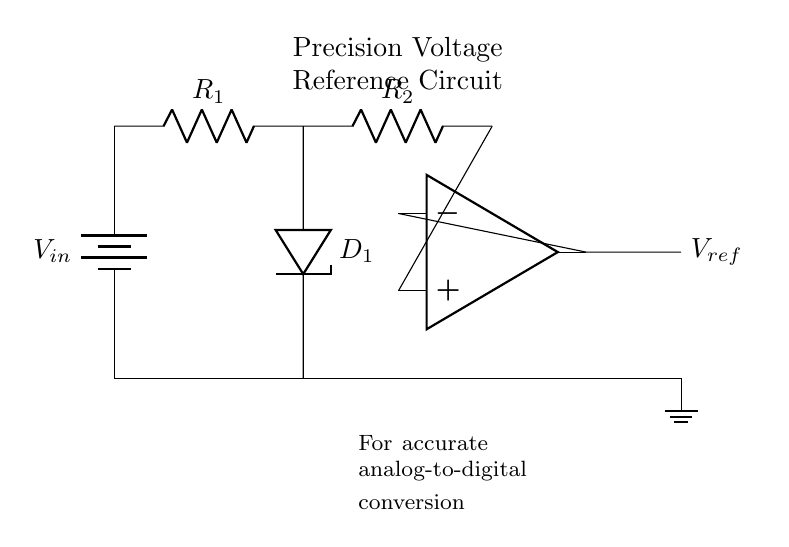What is the type of diode used in this circuit? The diagram indicates a Zener diode is used, which is represented as D1 in the circuit. Zener diodes are typically used for voltage regulation.
Answer: Zener diode What is the role of R1? Resistor R1 is connected in series with the input voltage supply, which limits the current flowing into the Zener diode to protect it from excessive current.
Answer: Current limiting What is the purpose of the operational amplifier in this circuit? The operational amplifier (op-amp) amplifies the voltage reference created by the Zener diode, providing a stable reference voltage output.
Answer: Voltage amplification Which component provides the reference voltage for the analog-to-digital conversion? The reference voltage is provided by the Zener diode, which maintains a constant voltage across its terminals, essential for accurate A/D conversion.
Answer: Zener diode What is the voltage across the Zener diode if it is properly biased? If properly biased, the Zener diode will be at its specified Zener voltage, maintaining that voltage level regardless of the current within limits.
Answer: Zener voltage How many resistors are present in the circuit? There are two resistors present: R1 and R2, which serve different purposes in the circuit.
Answer: Two resistors What is the primary function of this precision voltage reference circuit? The primary function is to provide an accurate and stable voltage reference for use in analog-to-digital conversion processes in electronic circuits.
Answer: Voltage reference 